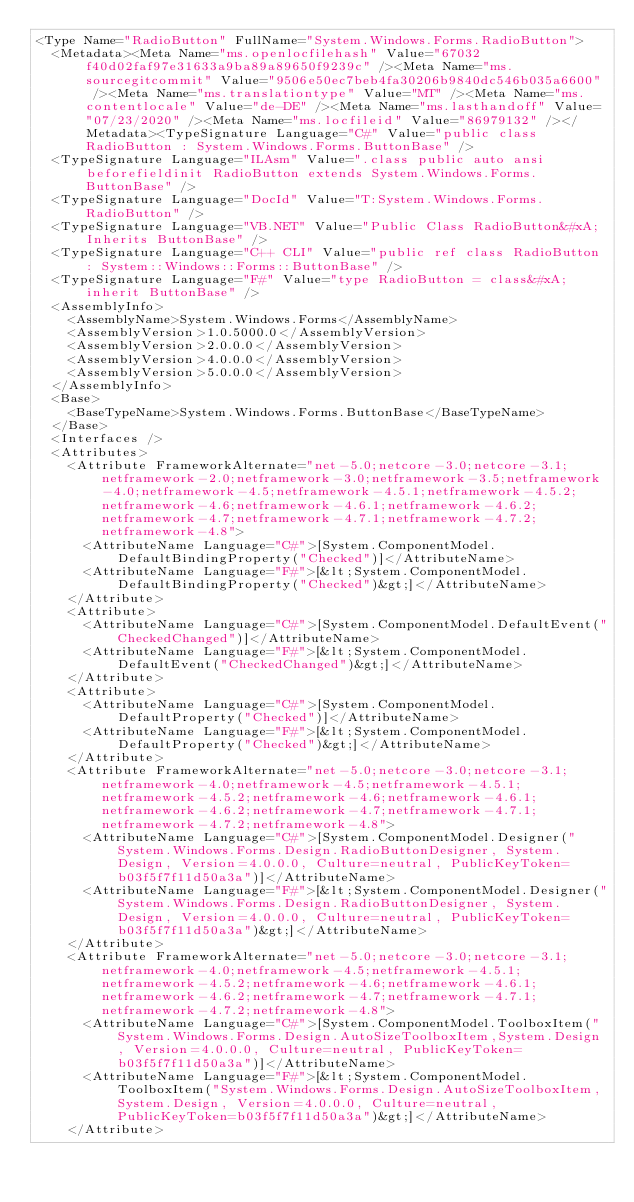<code> <loc_0><loc_0><loc_500><loc_500><_XML_><Type Name="RadioButton" FullName="System.Windows.Forms.RadioButton">
  <Metadata><Meta Name="ms.openlocfilehash" Value="67032f40d02faf97e31633a9ba89a89650f9239c" /><Meta Name="ms.sourcegitcommit" Value="9506e50ec7beb4fa30206b9840dc546b035a6600" /><Meta Name="ms.translationtype" Value="MT" /><Meta Name="ms.contentlocale" Value="de-DE" /><Meta Name="ms.lasthandoff" Value="07/23/2020" /><Meta Name="ms.locfileid" Value="86979132" /></Metadata><TypeSignature Language="C#" Value="public class RadioButton : System.Windows.Forms.ButtonBase" />
  <TypeSignature Language="ILAsm" Value=".class public auto ansi beforefieldinit RadioButton extends System.Windows.Forms.ButtonBase" />
  <TypeSignature Language="DocId" Value="T:System.Windows.Forms.RadioButton" />
  <TypeSignature Language="VB.NET" Value="Public Class RadioButton&#xA;Inherits ButtonBase" />
  <TypeSignature Language="C++ CLI" Value="public ref class RadioButton : System::Windows::Forms::ButtonBase" />
  <TypeSignature Language="F#" Value="type RadioButton = class&#xA;    inherit ButtonBase" />
  <AssemblyInfo>
    <AssemblyName>System.Windows.Forms</AssemblyName>
    <AssemblyVersion>1.0.5000.0</AssemblyVersion>
    <AssemblyVersion>2.0.0.0</AssemblyVersion>
    <AssemblyVersion>4.0.0.0</AssemblyVersion>
    <AssemblyVersion>5.0.0.0</AssemblyVersion>
  </AssemblyInfo>
  <Base>
    <BaseTypeName>System.Windows.Forms.ButtonBase</BaseTypeName>
  </Base>
  <Interfaces />
  <Attributes>
    <Attribute FrameworkAlternate="net-5.0;netcore-3.0;netcore-3.1;netframework-2.0;netframework-3.0;netframework-3.5;netframework-4.0;netframework-4.5;netframework-4.5.1;netframework-4.5.2;netframework-4.6;netframework-4.6.1;netframework-4.6.2;netframework-4.7;netframework-4.7.1;netframework-4.7.2;netframework-4.8">
      <AttributeName Language="C#">[System.ComponentModel.DefaultBindingProperty("Checked")]</AttributeName>
      <AttributeName Language="F#">[&lt;System.ComponentModel.DefaultBindingProperty("Checked")&gt;]</AttributeName>
    </Attribute>
    <Attribute>
      <AttributeName Language="C#">[System.ComponentModel.DefaultEvent("CheckedChanged")]</AttributeName>
      <AttributeName Language="F#">[&lt;System.ComponentModel.DefaultEvent("CheckedChanged")&gt;]</AttributeName>
    </Attribute>
    <Attribute>
      <AttributeName Language="C#">[System.ComponentModel.DefaultProperty("Checked")]</AttributeName>
      <AttributeName Language="F#">[&lt;System.ComponentModel.DefaultProperty("Checked")&gt;]</AttributeName>
    </Attribute>
    <Attribute FrameworkAlternate="net-5.0;netcore-3.0;netcore-3.1;netframework-4.0;netframework-4.5;netframework-4.5.1;netframework-4.5.2;netframework-4.6;netframework-4.6.1;netframework-4.6.2;netframework-4.7;netframework-4.7.1;netframework-4.7.2;netframework-4.8">
      <AttributeName Language="C#">[System.ComponentModel.Designer("System.Windows.Forms.Design.RadioButtonDesigner, System.Design, Version=4.0.0.0, Culture=neutral, PublicKeyToken=b03f5f7f11d50a3a")]</AttributeName>
      <AttributeName Language="F#">[&lt;System.ComponentModel.Designer("System.Windows.Forms.Design.RadioButtonDesigner, System.Design, Version=4.0.0.0, Culture=neutral, PublicKeyToken=b03f5f7f11d50a3a")&gt;]</AttributeName>
    </Attribute>
    <Attribute FrameworkAlternate="net-5.0;netcore-3.0;netcore-3.1;netframework-4.0;netframework-4.5;netframework-4.5.1;netframework-4.5.2;netframework-4.6;netframework-4.6.1;netframework-4.6.2;netframework-4.7;netframework-4.7.1;netframework-4.7.2;netframework-4.8">
      <AttributeName Language="C#">[System.ComponentModel.ToolboxItem("System.Windows.Forms.Design.AutoSizeToolboxItem,System.Design, Version=4.0.0.0, Culture=neutral, PublicKeyToken=b03f5f7f11d50a3a")]</AttributeName>
      <AttributeName Language="F#">[&lt;System.ComponentModel.ToolboxItem("System.Windows.Forms.Design.AutoSizeToolboxItem,System.Design, Version=4.0.0.0, Culture=neutral, PublicKeyToken=b03f5f7f11d50a3a")&gt;]</AttributeName>
    </Attribute></code> 